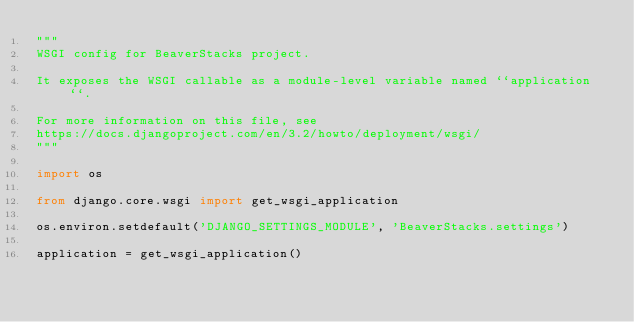<code> <loc_0><loc_0><loc_500><loc_500><_Python_>"""
WSGI config for BeaverStacks project.

It exposes the WSGI callable as a module-level variable named ``application``.

For more information on this file, see
https://docs.djangoproject.com/en/3.2/howto/deployment/wsgi/
"""

import os

from django.core.wsgi import get_wsgi_application

os.environ.setdefault('DJANGO_SETTINGS_MODULE', 'BeaverStacks.settings')

application = get_wsgi_application()
</code> 